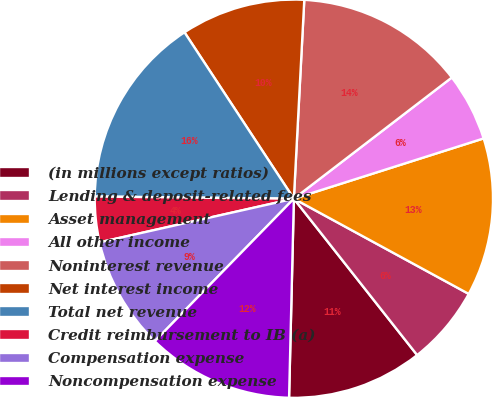Convert chart to OTSL. <chart><loc_0><loc_0><loc_500><loc_500><pie_chart><fcel>(in millions except ratios)<fcel>Lending & deposit-related fees<fcel>Asset management<fcel>All other income<fcel>Noninterest revenue<fcel>Net interest income<fcel>Total net revenue<fcel>Credit reimbursement to IB (a)<fcel>Compensation expense<fcel>Noncompensation expense<nl><fcel>11.01%<fcel>6.44%<fcel>12.83%<fcel>5.52%<fcel>13.75%<fcel>10.09%<fcel>15.57%<fcel>3.69%<fcel>9.18%<fcel>11.92%<nl></chart> 